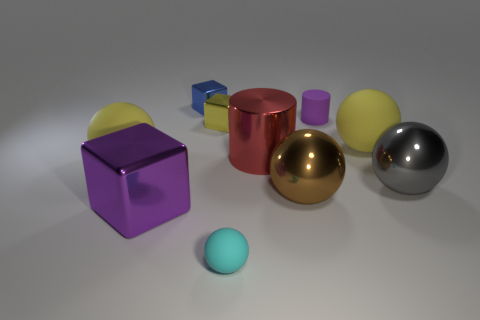Are there any other things that have the same size as the red metal cylinder?
Offer a very short reply. Yes. What number of objects are either large purple metallic blocks or big balls?
Your response must be concise. 5. What shape is the big gray object that is made of the same material as the big red cylinder?
Keep it short and to the point. Sphere. How big is the yellow ball right of the big yellow sphere to the left of the red object?
Provide a succinct answer. Large. How many tiny things are either gray metallic balls or blue blocks?
Offer a very short reply. 1. What number of other objects are the same color as the large shiny cylinder?
Keep it short and to the point. 0. Do the cylinder that is behind the red metal object and the brown thing in front of the tiny rubber cylinder have the same size?
Offer a terse response. No. Is the big brown object made of the same material as the yellow object left of the yellow cube?
Keep it short and to the point. No. Is the number of gray things that are on the right side of the tiny yellow block greater than the number of shiny objects on the right side of the large gray object?
Your response must be concise. Yes. There is a large matte ball that is behind the yellow rubber object left of the brown shiny sphere; what color is it?
Provide a succinct answer. Yellow. 